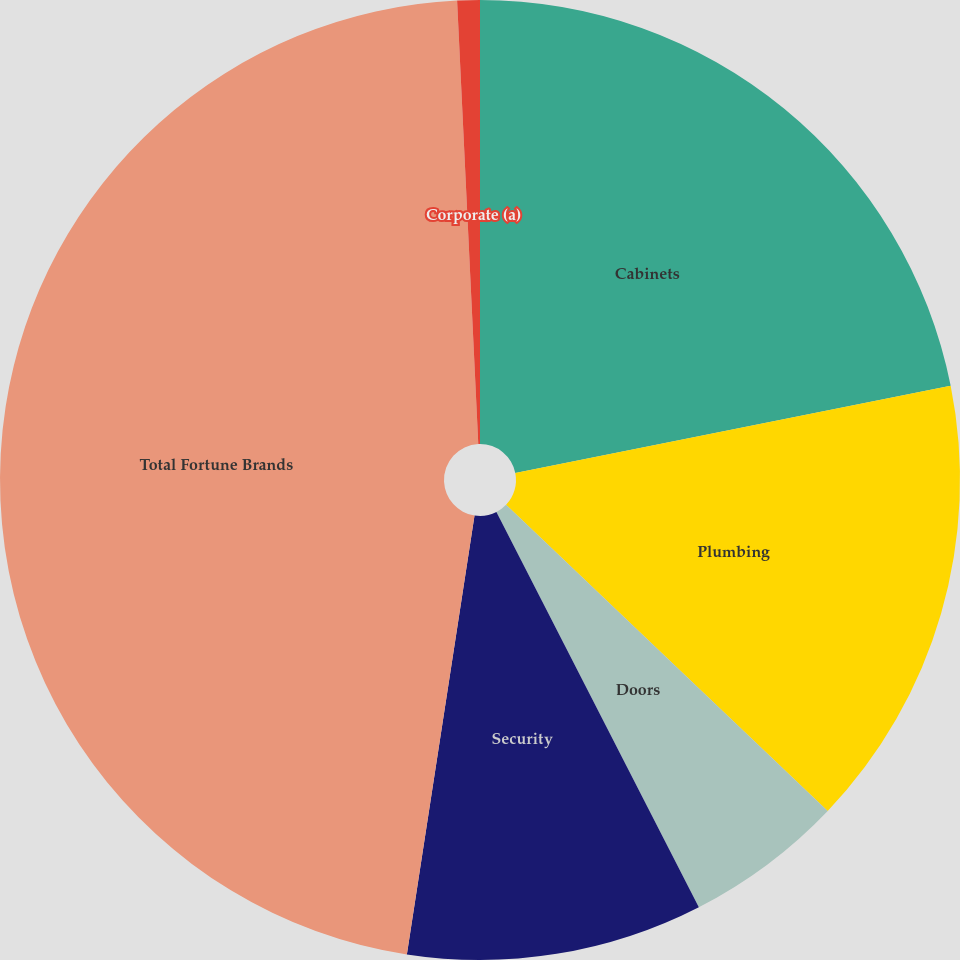Convert chart. <chart><loc_0><loc_0><loc_500><loc_500><pie_chart><fcel>Cabinets<fcel>Plumbing<fcel>Doors<fcel>Security<fcel>Total Fortune Brands<fcel>Corporate (a)<nl><fcel>21.86%<fcel>15.25%<fcel>5.36%<fcel>9.97%<fcel>46.81%<fcel>0.76%<nl></chart> 